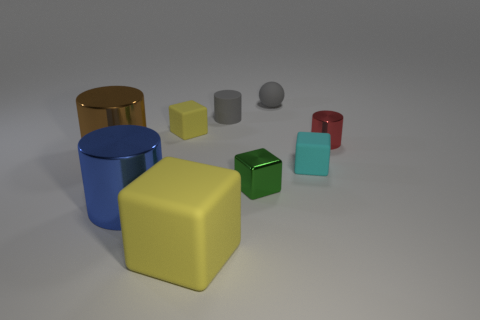There is a small thing on the left side of the large matte cube; what material is it?
Keep it short and to the point. Rubber. What size is the brown thing that is made of the same material as the red cylinder?
Make the answer very short. Large. How many small objects are the same shape as the large blue thing?
Offer a terse response. 2. Do the red thing and the tiny green metal object in front of the matte sphere have the same shape?
Provide a succinct answer. No. There is a rubber object that is the same color as the small matte cylinder; what shape is it?
Offer a very short reply. Sphere. Are there any spheres that have the same material as the blue thing?
Your answer should be compact. No. Is there anything else that has the same material as the tiny cyan block?
Offer a very short reply. Yes. There is a large cylinder that is right of the big metal cylinder that is behind the blue cylinder; what is its material?
Provide a short and direct response. Metal. What is the size of the block on the left side of the yellow cube that is in front of the matte cube behind the red shiny thing?
Provide a short and direct response. Small. What number of other things are there of the same shape as the tiny green object?
Provide a succinct answer. 3. 